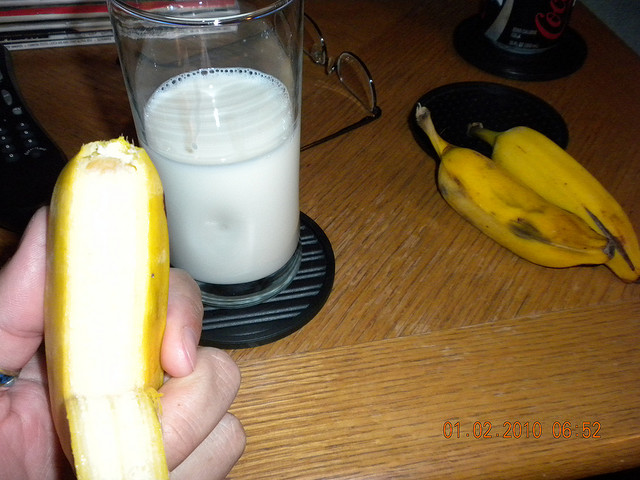Identify the text displayed in this image. 01 02 2010 06 52 